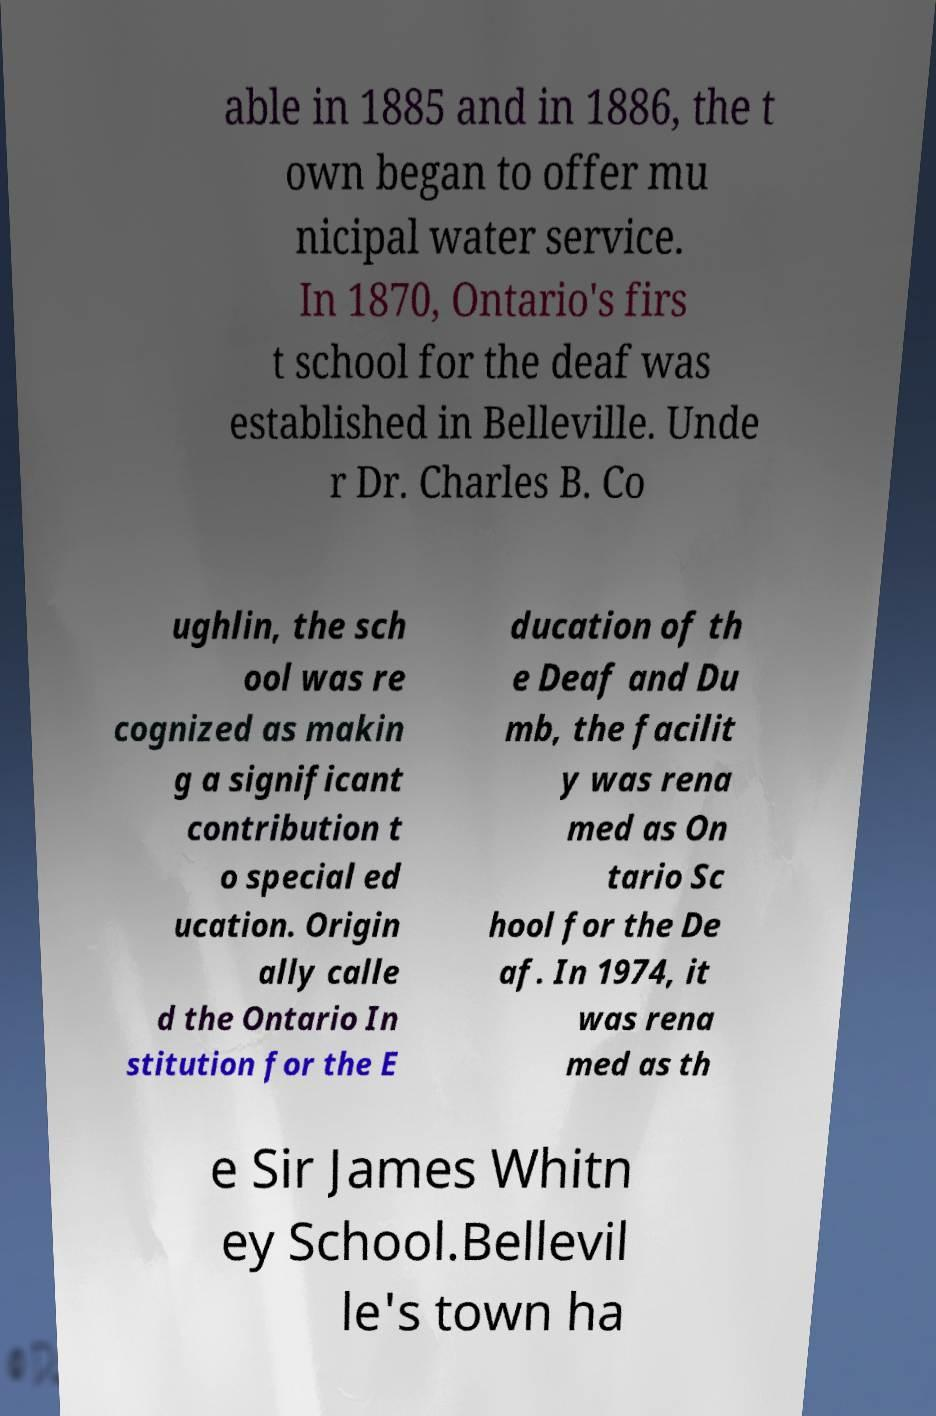There's text embedded in this image that I need extracted. Can you transcribe it verbatim? able in 1885 and in 1886, the t own began to offer mu nicipal water service. In 1870, Ontario's firs t school for the deaf was established in Belleville. Unde r Dr. Charles B. Co ughlin, the sch ool was re cognized as makin g a significant contribution t o special ed ucation. Origin ally calle d the Ontario In stitution for the E ducation of th e Deaf and Du mb, the facilit y was rena med as On tario Sc hool for the De af. In 1974, it was rena med as th e Sir James Whitn ey School.Bellevil le's town ha 